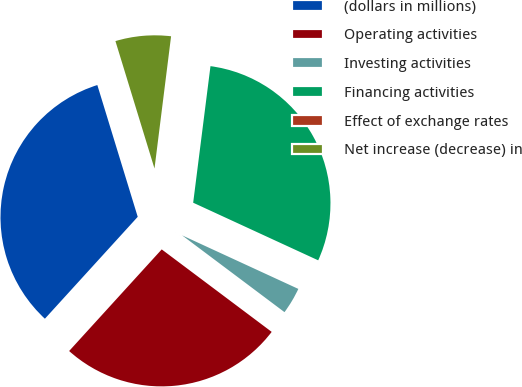Convert chart to OTSL. <chart><loc_0><loc_0><loc_500><loc_500><pie_chart><fcel>(dollars in millions)<fcel>Operating activities<fcel>Investing activities<fcel>Financing activities<fcel>Effect of exchange rates<fcel>Net increase (decrease) in<nl><fcel>33.51%<fcel>26.52%<fcel>3.37%<fcel>29.87%<fcel>0.02%<fcel>6.72%<nl></chart> 